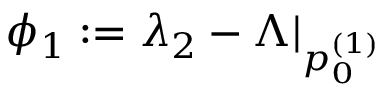<formula> <loc_0><loc_0><loc_500><loc_500>\phi _ { 1 } \colon = \lambda _ { 2 } - \Lambda | _ { p _ { 0 } ^ { ( 1 ) } }</formula> 